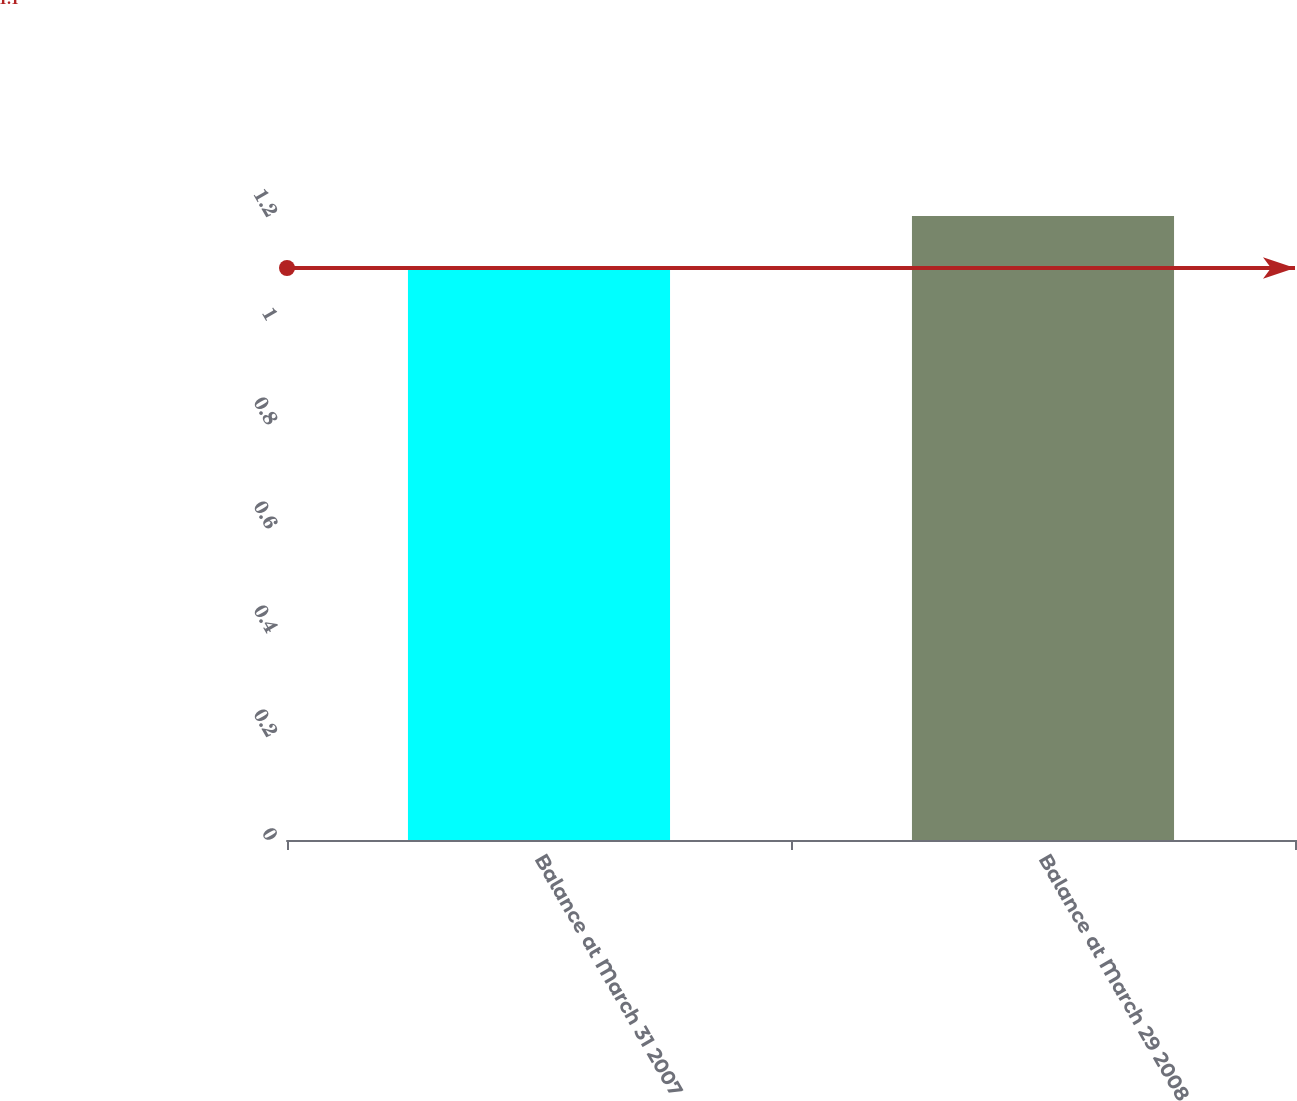Convert chart to OTSL. <chart><loc_0><loc_0><loc_500><loc_500><bar_chart><fcel>Balance at March 31 2007<fcel>Balance at March 29 2008<nl><fcel>1.1<fcel>1.2<nl></chart> 